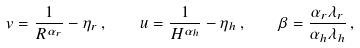<formula> <loc_0><loc_0><loc_500><loc_500>v = \frac { 1 } { R ^ { \alpha _ { r } } } - \eta _ { r } \, , \quad u = \frac { 1 } { H ^ { \alpha _ { h } } } - \eta _ { h } \, , \quad \beta = \frac { \alpha _ { r } \lambda _ { r } } { \alpha _ { h } \lambda _ { h } } \, ,</formula> 